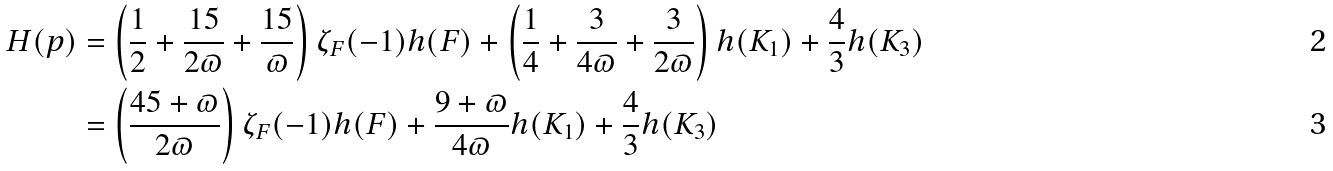Convert formula to latex. <formula><loc_0><loc_0><loc_500><loc_500>H ( p ) & = \left ( \frac { 1 } { 2 } + \frac { 1 5 } { 2 \varpi } + \frac { 1 5 } { \varpi } \right ) \zeta _ { F } ( - 1 ) h ( F ) + \left ( \frac { 1 } { 4 } + \frac { 3 } { 4 \varpi } + \frac { 3 } { 2 \varpi } \right ) h ( K _ { 1 } ) + \frac { 4 } { 3 } h ( K _ { 3 } ) \\ & = \left ( \frac { 4 5 + \varpi } { 2 \varpi } \right ) \zeta _ { F } ( - 1 ) h ( F ) + \frac { 9 + \varpi } { 4 \varpi } h ( K _ { 1 } ) + \frac { 4 } { 3 } h ( K _ { 3 } )</formula> 